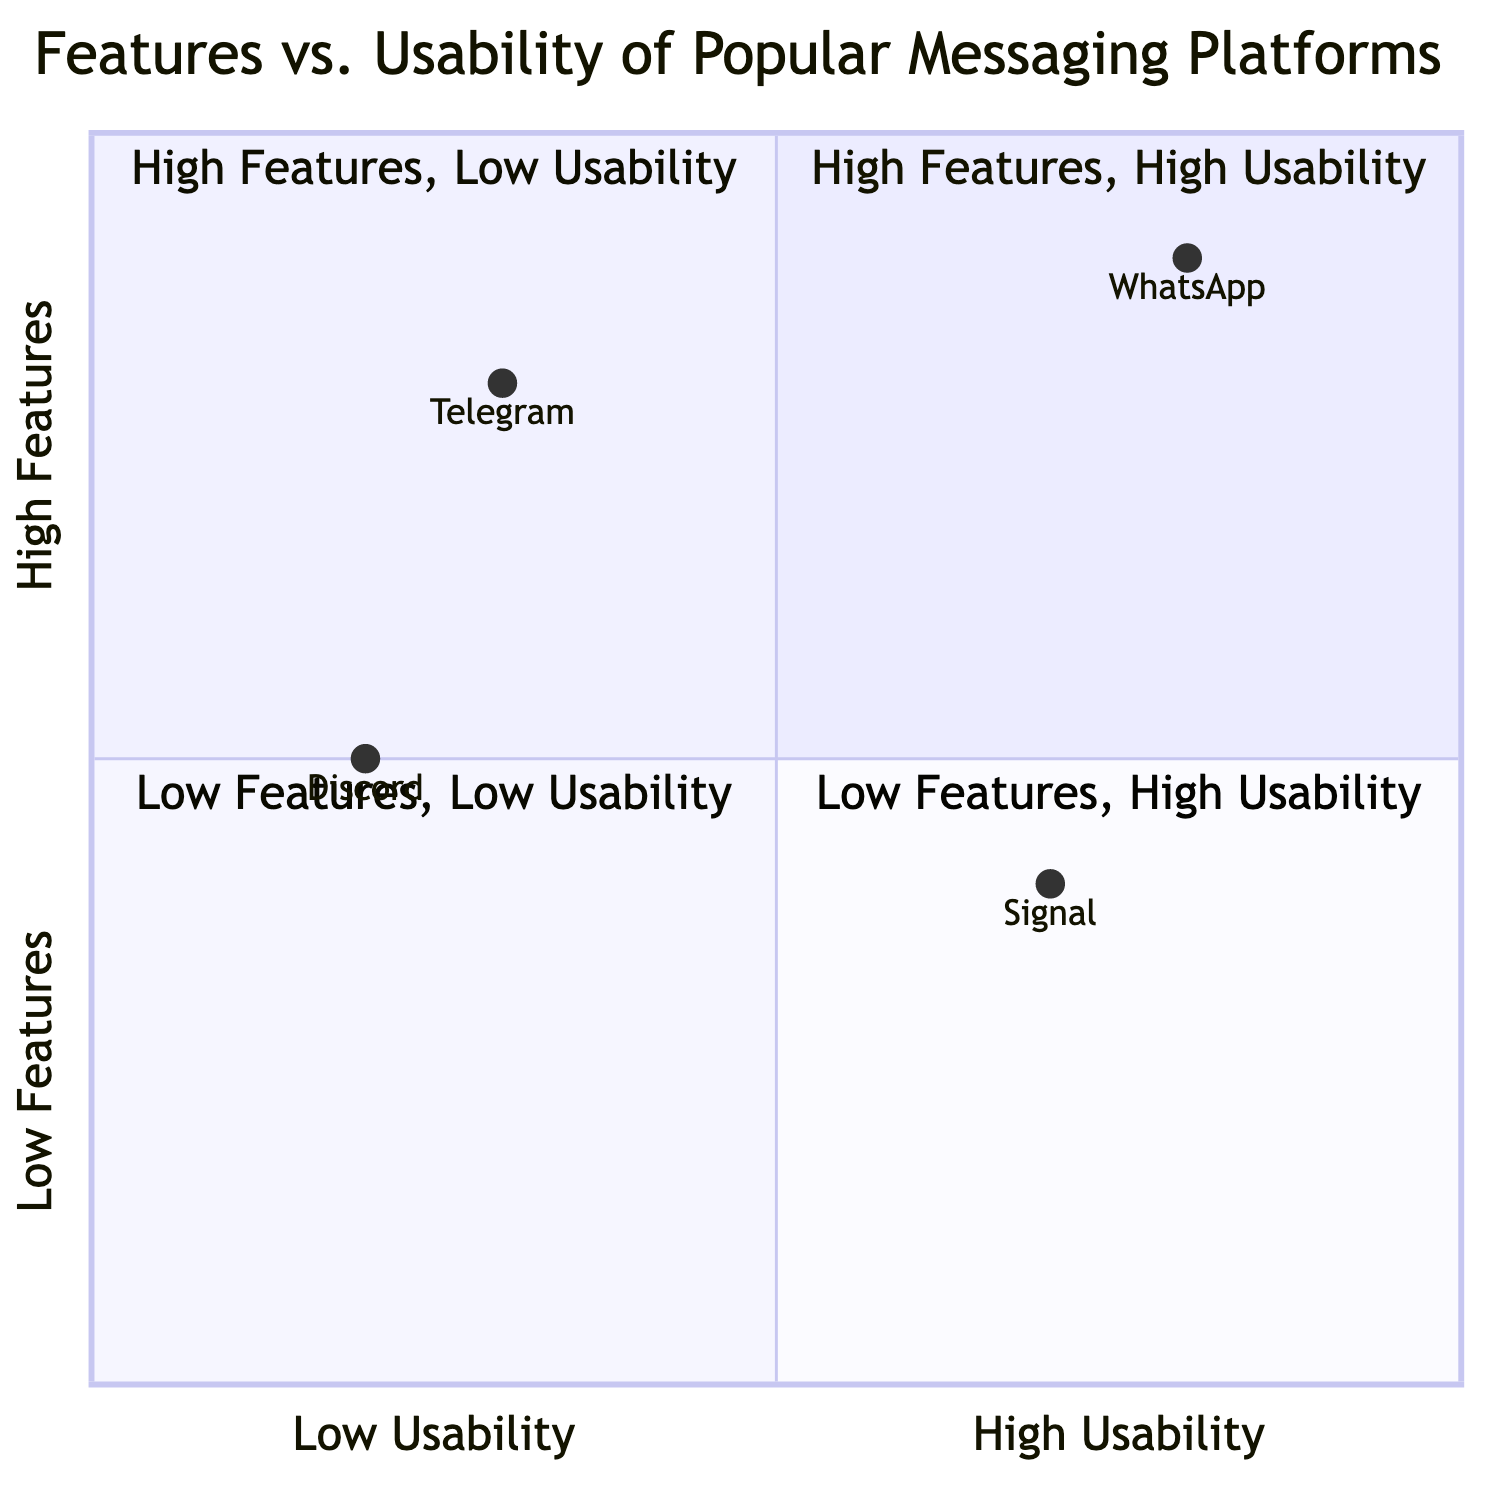What is the platform with high features and high usability? The diagram shows that WhatsApp is categorized in the quadrant labeled "High Features, High Usability" with specific features and a user-friendly interface.
Answer: WhatsApp Which platform is known for its complex usability despite having many features? Telegram is placed in the "High Features, Low Usability" quadrant, indicating that while it has many features, it can be complex for new users.
Answer: Telegram What features does Signal provide? Signal, located in the "Low Features, High Usability" quadrant, includes features such as End-to-End Encryption, Self-Destructing Messages, and Voice and Video Calls.
Answer: End-to-End Encryption, Self-Destructing Messages, Voice and Video Calls Which platform has the lowest usability according to the diagram? Discord is positioned in the "Low Features, Low Usability" quadrant, indicating it has a steeper learning curve for new users.
Answer: Discord How many platforms are in the "High Features, Low Usability" quadrant? The diagram shows only one platform in that quadrant, which is Telegram, thus indicating the sparsity of platforms with high features but low usability.
Answer: One What is the relationship between usability and features for Signal? Signal has low features and high usability, indicating that while it does not offer a wide range of features, it is easy to use, focusing on privacy.
Answer: Low features, high usability Which platform is described as having a gamer-centric usability? The diagram associates Discord with a user experience catered to gamers, leading to a learning curve for new users.
Answer: Discord What does the "High Features, High Usability" quadrant indicate about WhatsApp's features? It shows that WhatsApp has a variety of features while also being user-friendly, making it approachable for most users.
Answer: Variety of features, user-friendly 